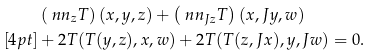Convert formula to latex. <formula><loc_0><loc_0><loc_500><loc_500>& \left ( \ n n _ { z } T \right ) ( x , y , z ) + \left ( \ n n _ { J z } T \right ) ( x , J y , w ) \\ [ 4 p t ] & + 2 T ( T ( y , z ) , x , w ) + 2 T ( T ( z , J x ) , y , J w ) = 0 .</formula> 